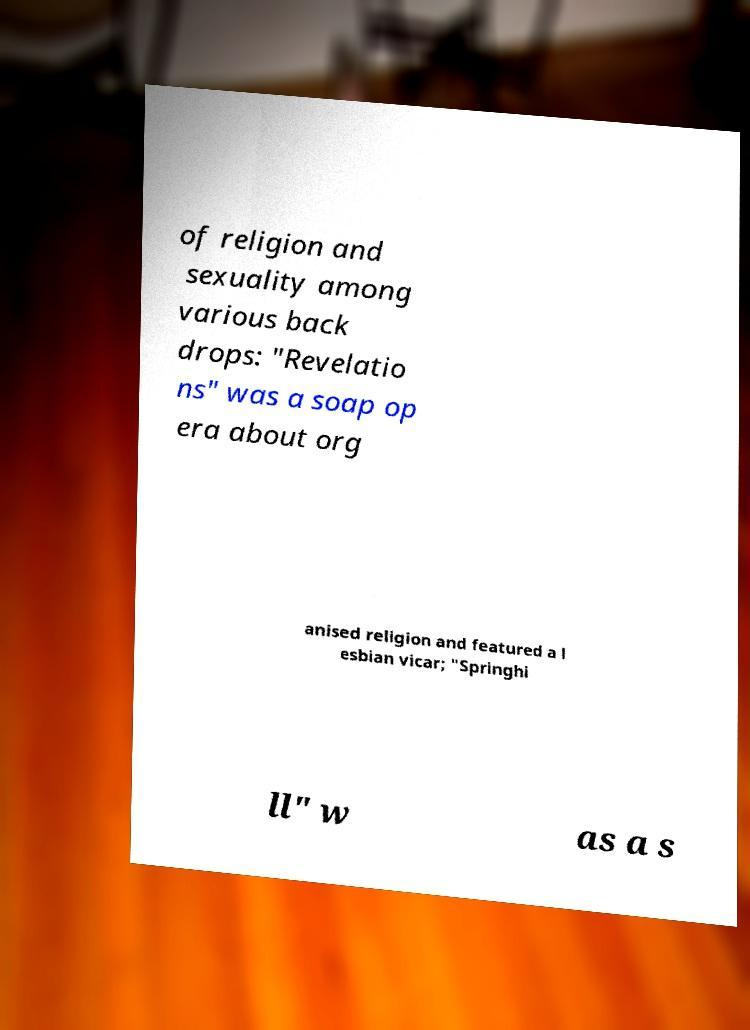Could you extract and type out the text from this image? of religion and sexuality among various back drops: "Revelatio ns" was a soap op era about org anised religion and featured a l esbian vicar; "Springhi ll" w as a s 